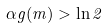<formula> <loc_0><loc_0><loc_500><loc_500>\alpha g ( m ) > \ln 2</formula> 